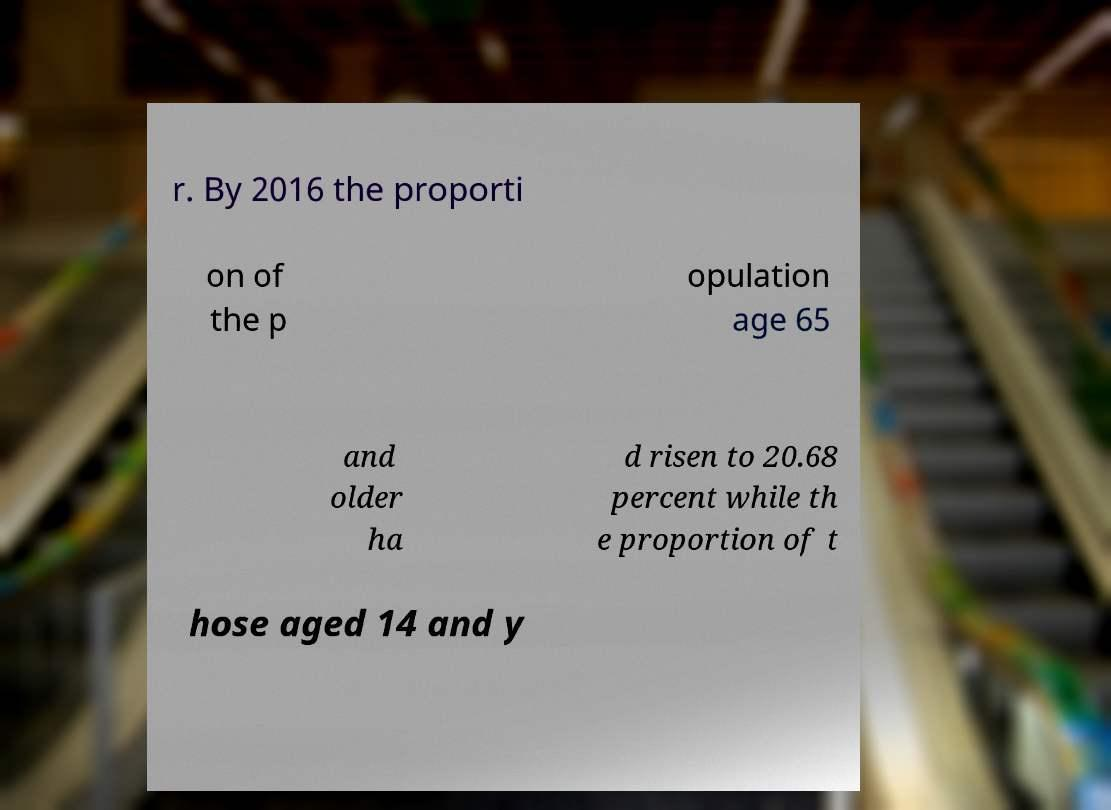I need the written content from this picture converted into text. Can you do that? r. By 2016 the proporti on of the p opulation age 65 and older ha d risen to 20.68 percent while th e proportion of t hose aged 14 and y 